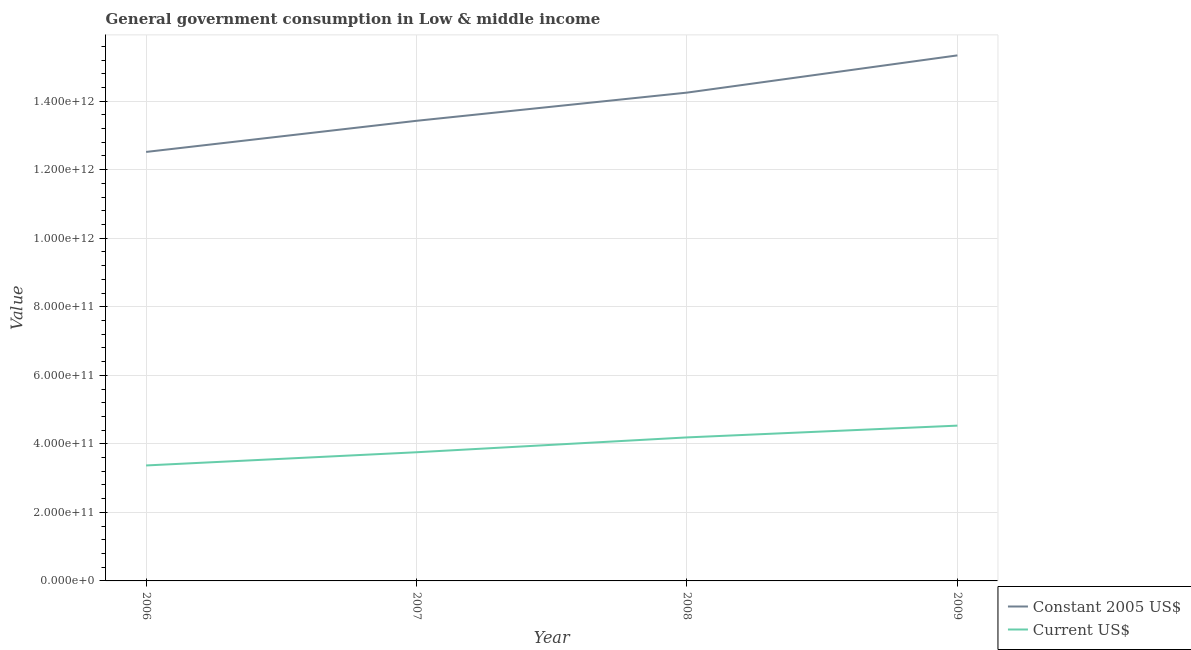How many different coloured lines are there?
Provide a short and direct response. 2. Does the line corresponding to value consumed in current us$ intersect with the line corresponding to value consumed in constant 2005 us$?
Your response must be concise. No. Is the number of lines equal to the number of legend labels?
Give a very brief answer. Yes. What is the value consumed in current us$ in 2006?
Your response must be concise. 3.37e+11. Across all years, what is the maximum value consumed in current us$?
Offer a very short reply. 4.53e+11. Across all years, what is the minimum value consumed in constant 2005 us$?
Ensure brevity in your answer.  1.25e+12. In which year was the value consumed in constant 2005 us$ maximum?
Give a very brief answer. 2009. In which year was the value consumed in constant 2005 us$ minimum?
Offer a very short reply. 2006. What is the total value consumed in current us$ in the graph?
Provide a short and direct response. 1.58e+12. What is the difference between the value consumed in constant 2005 us$ in 2008 and that in 2009?
Give a very brief answer. -1.09e+11. What is the difference between the value consumed in constant 2005 us$ in 2007 and the value consumed in current us$ in 2006?
Keep it short and to the point. 1.01e+12. What is the average value consumed in constant 2005 us$ per year?
Your response must be concise. 1.39e+12. In the year 2009, what is the difference between the value consumed in current us$ and value consumed in constant 2005 us$?
Ensure brevity in your answer.  -1.08e+12. In how many years, is the value consumed in current us$ greater than 720000000000?
Give a very brief answer. 0. What is the ratio of the value consumed in current us$ in 2007 to that in 2008?
Ensure brevity in your answer.  0.9. Is the value consumed in constant 2005 us$ in 2007 less than that in 2008?
Provide a short and direct response. Yes. What is the difference between the highest and the second highest value consumed in constant 2005 us$?
Give a very brief answer. 1.09e+11. What is the difference between the highest and the lowest value consumed in constant 2005 us$?
Ensure brevity in your answer.  2.82e+11. In how many years, is the value consumed in current us$ greater than the average value consumed in current us$ taken over all years?
Ensure brevity in your answer.  2. Is the sum of the value consumed in current us$ in 2007 and 2009 greater than the maximum value consumed in constant 2005 us$ across all years?
Offer a terse response. No. How many years are there in the graph?
Your answer should be very brief. 4. What is the difference between two consecutive major ticks on the Y-axis?
Give a very brief answer. 2.00e+11. How many legend labels are there?
Provide a short and direct response. 2. What is the title of the graph?
Offer a very short reply. General government consumption in Low & middle income. Does "Nitrous oxide" appear as one of the legend labels in the graph?
Your answer should be compact. No. What is the label or title of the X-axis?
Provide a succinct answer. Year. What is the label or title of the Y-axis?
Your answer should be very brief. Value. What is the Value of Constant 2005 US$ in 2006?
Provide a succinct answer. 1.25e+12. What is the Value of Current US$ in 2006?
Provide a succinct answer. 3.37e+11. What is the Value in Constant 2005 US$ in 2007?
Give a very brief answer. 1.34e+12. What is the Value of Current US$ in 2007?
Provide a short and direct response. 3.75e+11. What is the Value of Constant 2005 US$ in 2008?
Provide a short and direct response. 1.42e+12. What is the Value in Current US$ in 2008?
Provide a short and direct response. 4.19e+11. What is the Value of Constant 2005 US$ in 2009?
Ensure brevity in your answer.  1.53e+12. What is the Value in Current US$ in 2009?
Ensure brevity in your answer.  4.53e+11. Across all years, what is the maximum Value in Constant 2005 US$?
Your answer should be compact. 1.53e+12. Across all years, what is the maximum Value of Current US$?
Offer a very short reply. 4.53e+11. Across all years, what is the minimum Value of Constant 2005 US$?
Your answer should be very brief. 1.25e+12. Across all years, what is the minimum Value in Current US$?
Make the answer very short. 3.37e+11. What is the total Value of Constant 2005 US$ in the graph?
Make the answer very short. 5.55e+12. What is the total Value of Current US$ in the graph?
Provide a succinct answer. 1.58e+12. What is the difference between the Value of Constant 2005 US$ in 2006 and that in 2007?
Your answer should be very brief. -9.09e+1. What is the difference between the Value in Current US$ in 2006 and that in 2007?
Offer a terse response. -3.85e+1. What is the difference between the Value in Constant 2005 US$ in 2006 and that in 2008?
Ensure brevity in your answer.  -1.73e+11. What is the difference between the Value in Current US$ in 2006 and that in 2008?
Your answer should be very brief. -8.18e+1. What is the difference between the Value of Constant 2005 US$ in 2006 and that in 2009?
Your response must be concise. -2.82e+11. What is the difference between the Value of Current US$ in 2006 and that in 2009?
Keep it short and to the point. -1.16e+11. What is the difference between the Value of Constant 2005 US$ in 2007 and that in 2008?
Your answer should be very brief. -8.22e+1. What is the difference between the Value of Current US$ in 2007 and that in 2008?
Your answer should be very brief. -4.33e+1. What is the difference between the Value of Constant 2005 US$ in 2007 and that in 2009?
Keep it short and to the point. -1.91e+11. What is the difference between the Value in Current US$ in 2007 and that in 2009?
Make the answer very short. -7.77e+1. What is the difference between the Value of Constant 2005 US$ in 2008 and that in 2009?
Keep it short and to the point. -1.09e+11. What is the difference between the Value in Current US$ in 2008 and that in 2009?
Provide a succinct answer. -3.44e+1. What is the difference between the Value in Constant 2005 US$ in 2006 and the Value in Current US$ in 2007?
Offer a terse response. 8.76e+11. What is the difference between the Value of Constant 2005 US$ in 2006 and the Value of Current US$ in 2008?
Your response must be concise. 8.33e+11. What is the difference between the Value of Constant 2005 US$ in 2006 and the Value of Current US$ in 2009?
Make the answer very short. 7.99e+11. What is the difference between the Value in Constant 2005 US$ in 2007 and the Value in Current US$ in 2008?
Offer a terse response. 9.24e+11. What is the difference between the Value in Constant 2005 US$ in 2007 and the Value in Current US$ in 2009?
Make the answer very short. 8.90e+11. What is the difference between the Value of Constant 2005 US$ in 2008 and the Value of Current US$ in 2009?
Offer a terse response. 9.72e+11. What is the average Value in Constant 2005 US$ per year?
Your response must be concise. 1.39e+12. What is the average Value in Current US$ per year?
Your response must be concise. 3.96e+11. In the year 2006, what is the difference between the Value in Constant 2005 US$ and Value in Current US$?
Your answer should be compact. 9.15e+11. In the year 2007, what is the difference between the Value of Constant 2005 US$ and Value of Current US$?
Offer a terse response. 9.67e+11. In the year 2008, what is the difference between the Value of Constant 2005 US$ and Value of Current US$?
Your answer should be very brief. 1.01e+12. In the year 2009, what is the difference between the Value in Constant 2005 US$ and Value in Current US$?
Make the answer very short. 1.08e+12. What is the ratio of the Value of Constant 2005 US$ in 2006 to that in 2007?
Give a very brief answer. 0.93. What is the ratio of the Value in Current US$ in 2006 to that in 2007?
Provide a succinct answer. 0.9. What is the ratio of the Value of Constant 2005 US$ in 2006 to that in 2008?
Offer a terse response. 0.88. What is the ratio of the Value of Current US$ in 2006 to that in 2008?
Offer a terse response. 0.8. What is the ratio of the Value of Constant 2005 US$ in 2006 to that in 2009?
Give a very brief answer. 0.82. What is the ratio of the Value of Current US$ in 2006 to that in 2009?
Offer a very short reply. 0.74. What is the ratio of the Value in Constant 2005 US$ in 2007 to that in 2008?
Your response must be concise. 0.94. What is the ratio of the Value of Current US$ in 2007 to that in 2008?
Keep it short and to the point. 0.9. What is the ratio of the Value in Constant 2005 US$ in 2007 to that in 2009?
Offer a very short reply. 0.88. What is the ratio of the Value of Current US$ in 2007 to that in 2009?
Provide a succinct answer. 0.83. What is the ratio of the Value of Constant 2005 US$ in 2008 to that in 2009?
Your response must be concise. 0.93. What is the ratio of the Value in Current US$ in 2008 to that in 2009?
Ensure brevity in your answer.  0.92. What is the difference between the highest and the second highest Value in Constant 2005 US$?
Give a very brief answer. 1.09e+11. What is the difference between the highest and the second highest Value in Current US$?
Offer a terse response. 3.44e+1. What is the difference between the highest and the lowest Value in Constant 2005 US$?
Provide a short and direct response. 2.82e+11. What is the difference between the highest and the lowest Value of Current US$?
Your answer should be compact. 1.16e+11. 